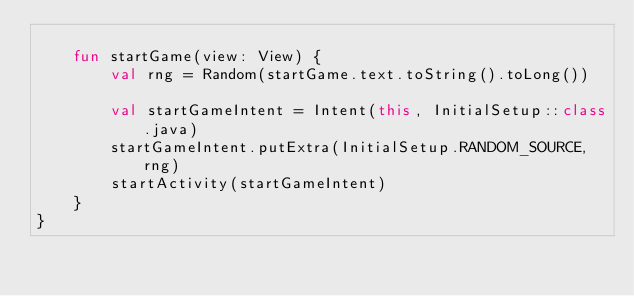<code> <loc_0><loc_0><loc_500><loc_500><_Kotlin_>
    fun startGame(view: View) {
        val rng = Random(startGame.text.toString().toLong())

        val startGameIntent = Intent(this, InitialSetup::class.java)
        startGameIntent.putExtra(InitialSetup.RANDOM_SOURCE, rng)
        startActivity(startGameIntent)
    }
}
</code> 